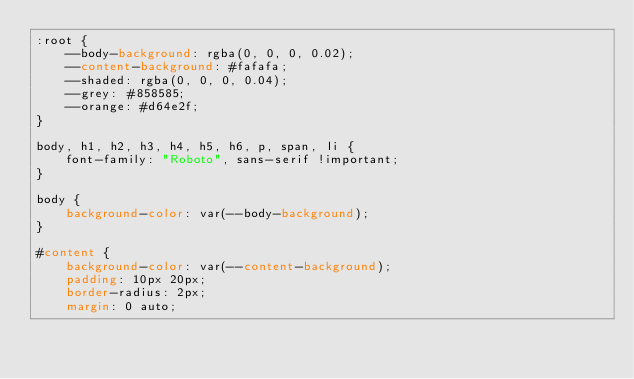Convert code to text. <code><loc_0><loc_0><loc_500><loc_500><_CSS_>:root {
    --body-background: rgba(0, 0, 0, 0.02);
    --content-background: #fafafa;
    --shaded: rgba(0, 0, 0, 0.04);
    --grey: #858585;
    --orange: #d64e2f;
}

body, h1, h2, h3, h4, h5, h6, p, span, li {
    font-family: "Roboto", sans-serif !important;
}

body {
    background-color: var(--body-background);
}

#content {
    background-color: var(--content-background);
    padding: 10px 20px;
    border-radius: 2px;
    margin: 0 auto;</code> 